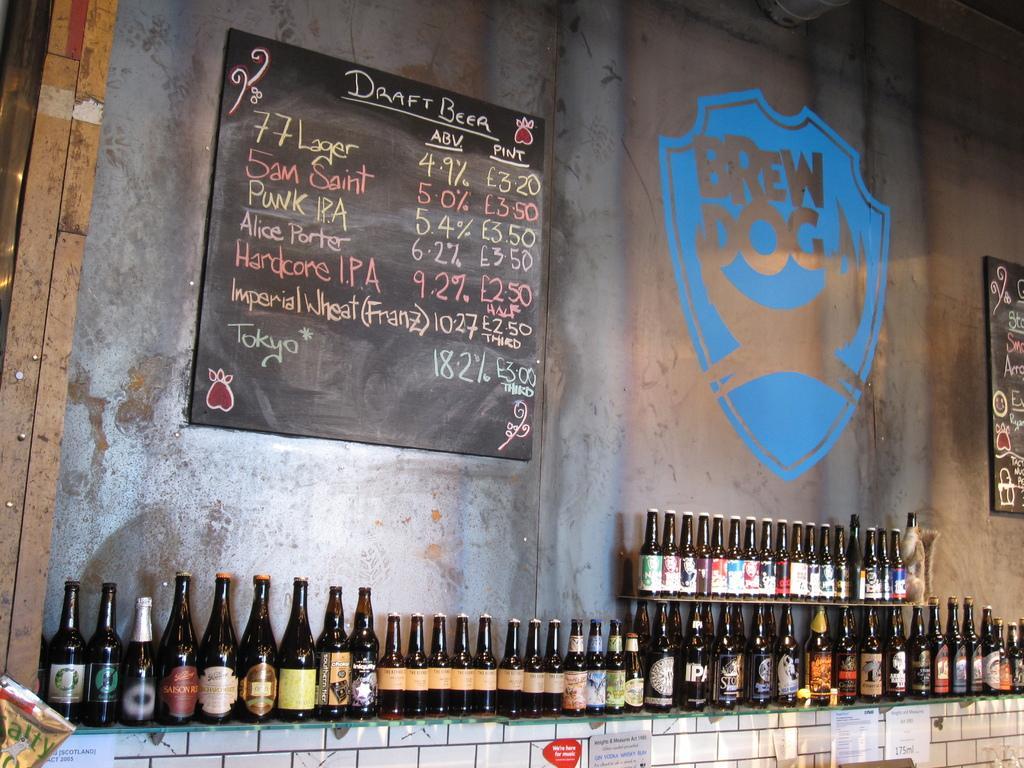How would you summarize this image in a sentence or two? In this picture we can see some series of alcohol bottles which are placed in a row, in the background we can see a wall and a black board and handwritten text on the board. 